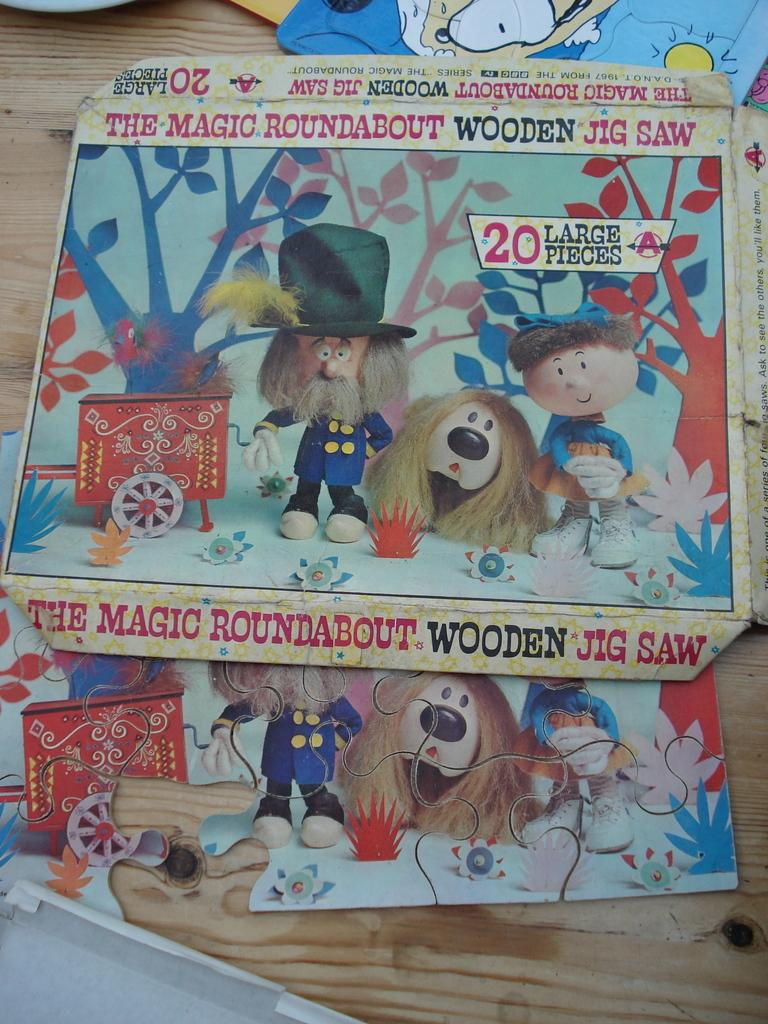What is the person holding in the image? The person is holding a guitar. Where is the person standing in the image? The person is standing on a stage. What else can be seen on the stage in the image? There are speakers on the stage. How many snakes are slithering across the stage in the image? There are no snakes present in the image; it features a person holding a guitar on a stage with speakers. What type of competition is being held on the stage in the image? There is no competition depicted in the image; it simply shows a person holding a guitar on a stage with speakers. 